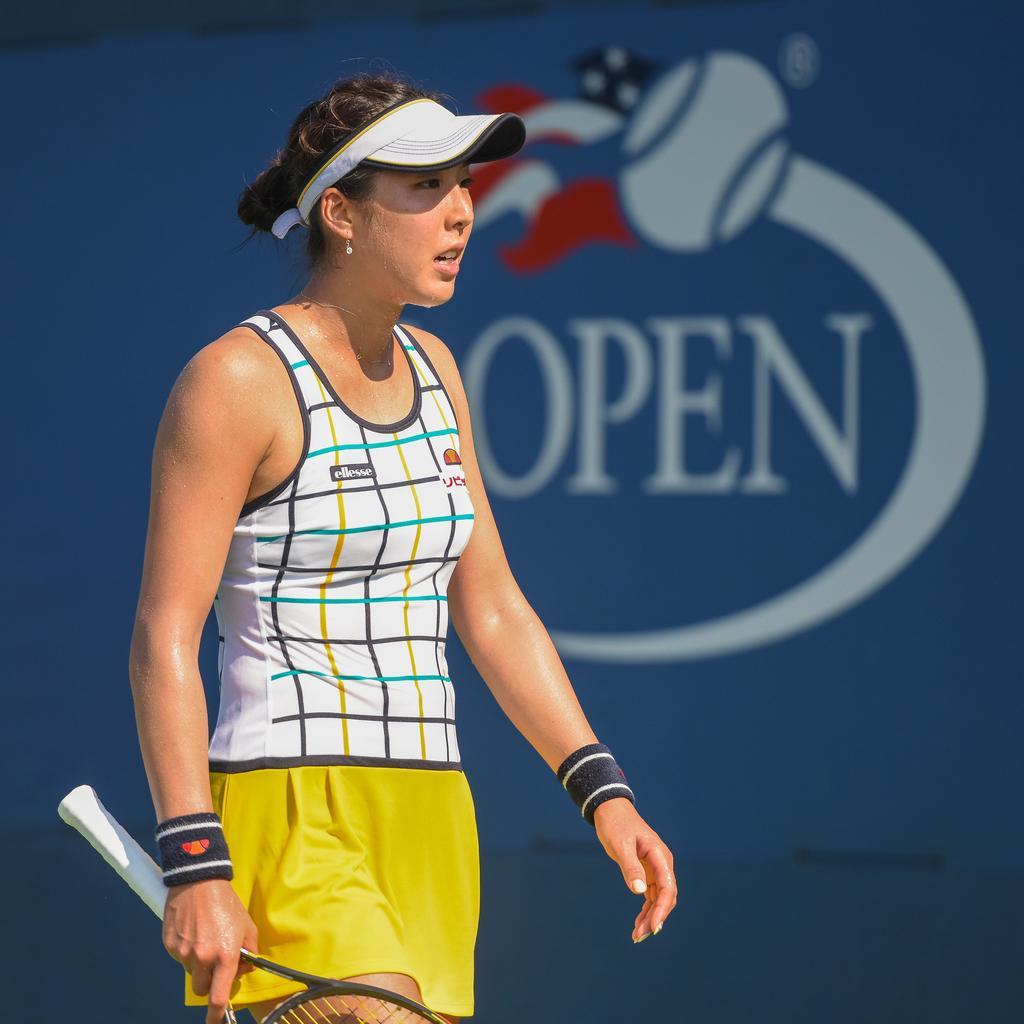In one or two sentences, can you explain what this image depicts? In this image a woman is holding a racket in her hand. She is wearing a cap. Behind her there is a banner having some text and a picture of a ball on it. 